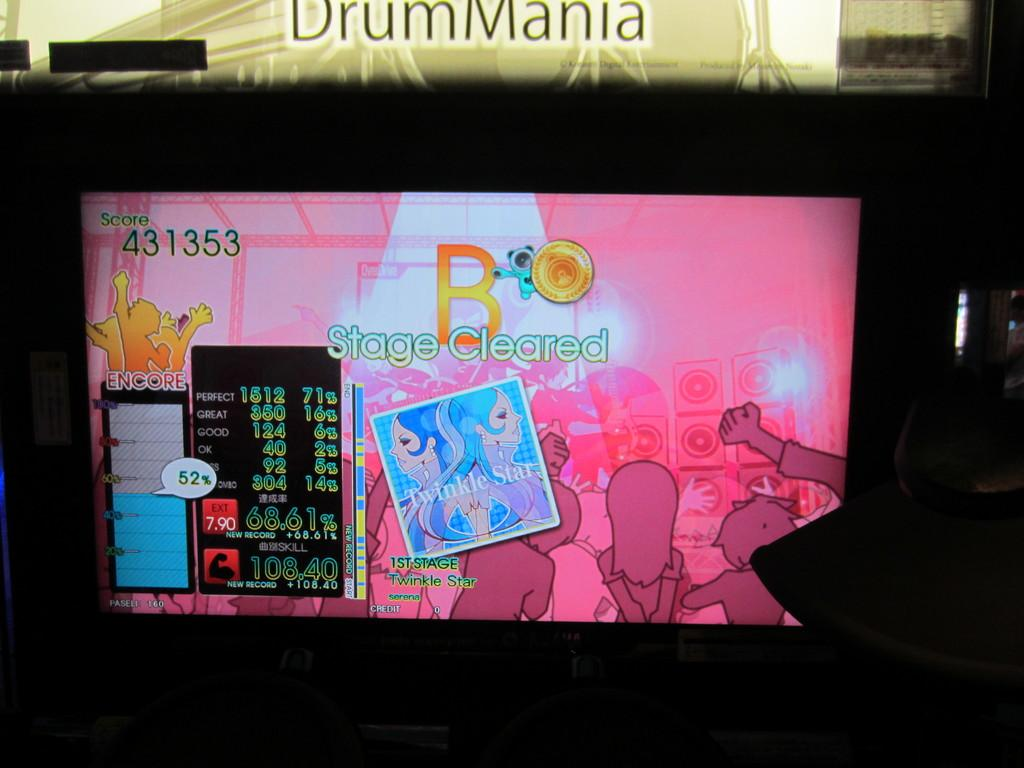Provide a one-sentence caption for the provided image. A game on the television with a stage cleared sign. 